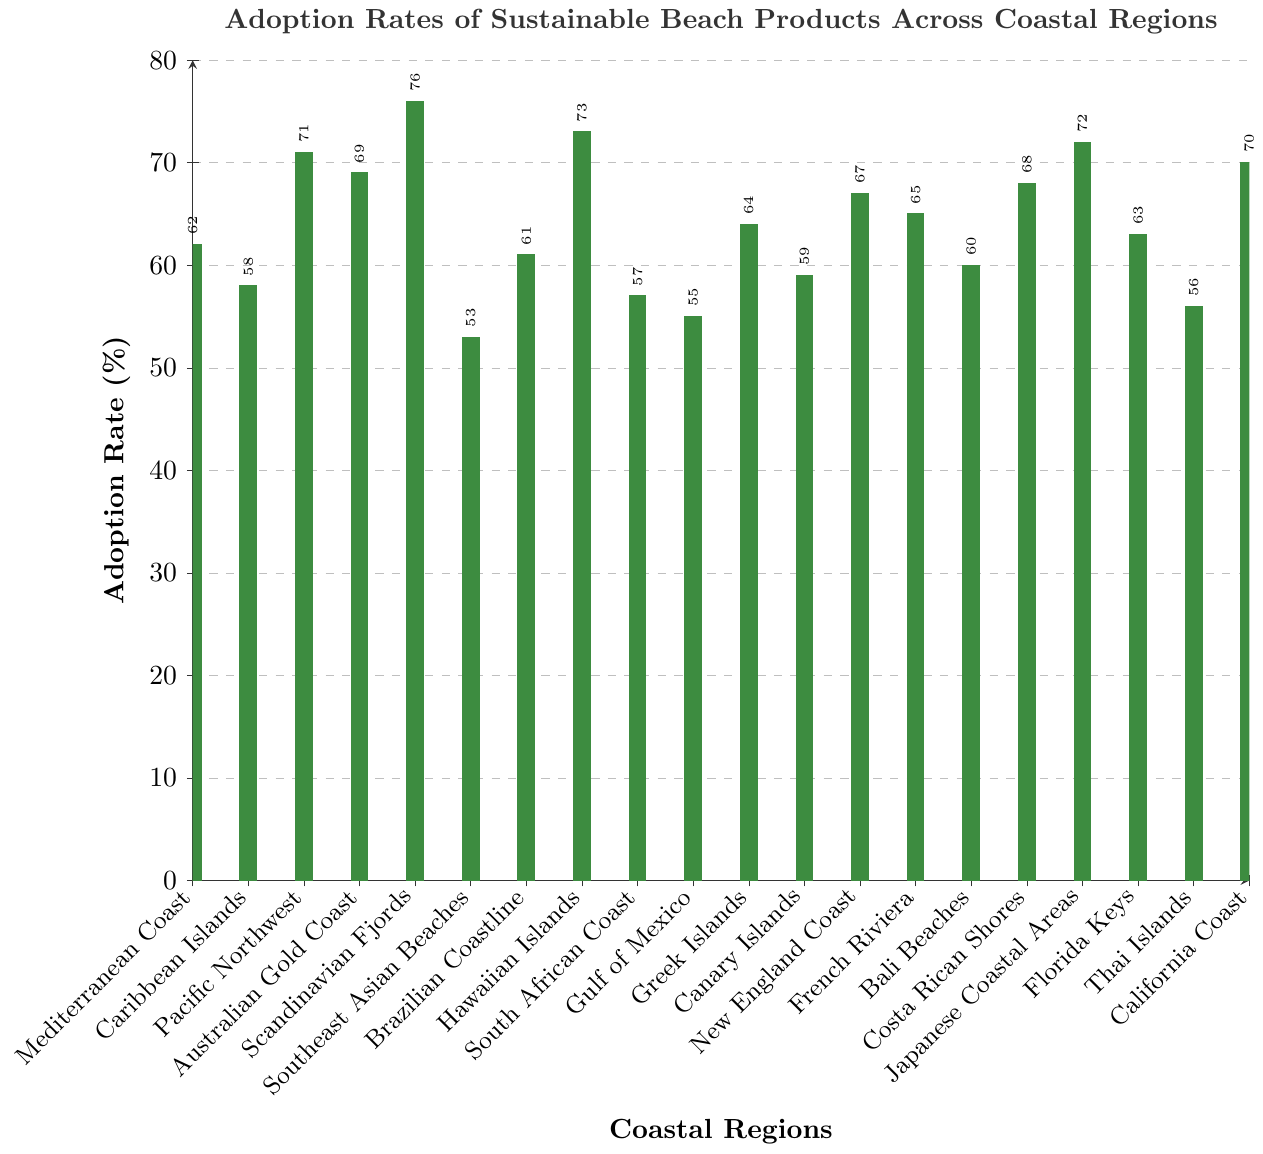What's the region with the highest adoption rate of sustainable beach products? The bar corresponding to Scandinavian Fjords is the tallest among all regions.
Answer: Scandinavian Fjords Which region has a higher adoption rate, Brazilian Coastline or Greek Islands? The bar for Greek Islands is taller than the bar for Brazilian Coastline.
Answer: Greek Islands How many regions have an adoption rate above 70%? The regions with bars above the 70% line are Pacific Northwest, Hawaiian Islands, Scandinavian Fjords, and Japanese Coastal Areas, which total 4 regions.
Answer: 4 What is the difference in adoption rates between Thai Islands and Gulf of Mexico? The adoption rate for Gulf of Mexico is 55% and for Thai Islands is 56%. The difference is 56% - 55% = 1%.
Answer: 1% What's the median adoption rate value across all regions? First, list all adoption rates: 53, 55, 56, 57, 58, 59, 60, 61, 62, 63, 64, 65, 67, 68, 69, 70, 71, 72, 73, 76. The middle values in the ordered list are 64 and 65. The median is (64 + 65) / 2 = 64.5%.
Answer: 64.5% How much higher is the adoption rate in the Mediterranean Coast compared to the Southeast Asian Beaches? The bar for Mediterranean Coast is 62% and for Southeast Asian Beaches is 53%. The difference is 62% - 53% = 9%.
Answer: 9% Are there more regions with adoption rates above 60% or below 60%? The regions with adoption rates above 60% are Mediterranean Coast, Pacific Northwest, Australian Gold Coast, Scandinavian Fjords, Brazilian Coastline, Hawaiian Islands, Greek Islands, New England Coast, French Riviera, Costa Rican Shores, Japanese Coastal Areas, California Coast, and Florida Keys. There are 13 regions in total. The regions with adoption rates below 60% are Caribbean Islands, Southeast Asian Beaches, South African Coast, Gulf of Mexico, Canary Islands, and Thai Islands, totaling 6 regions.
Answer: Above 60% What's the average adoption rate of sustainable beach products across all regions? Sum of all adoption rates is 62 + 58 + 71 + 69 + 76 + 53 + 61 + 73 + 57 + 55 + 64 + 59 + 67 + 65 + 60 + 68 + 72 + 63 + 56 + 70 = 1183. The average is 1183 / 20 = 59.15%.
Answer: 59.15% Which region has the second highest adoption rate? The tallest bar is for Scandinavian Fjords at 76%, and the second tallest is for Hawaiian Islands at 73%.
Answer: Hawaiian Islands What is the sum of the adoption rates for the Mediterranean Coast, Caribbean Islands, and Pacific Northwest? Adding the adoption rates of these regions: 62 + 58 + 71 = 191.
Answer: 191 